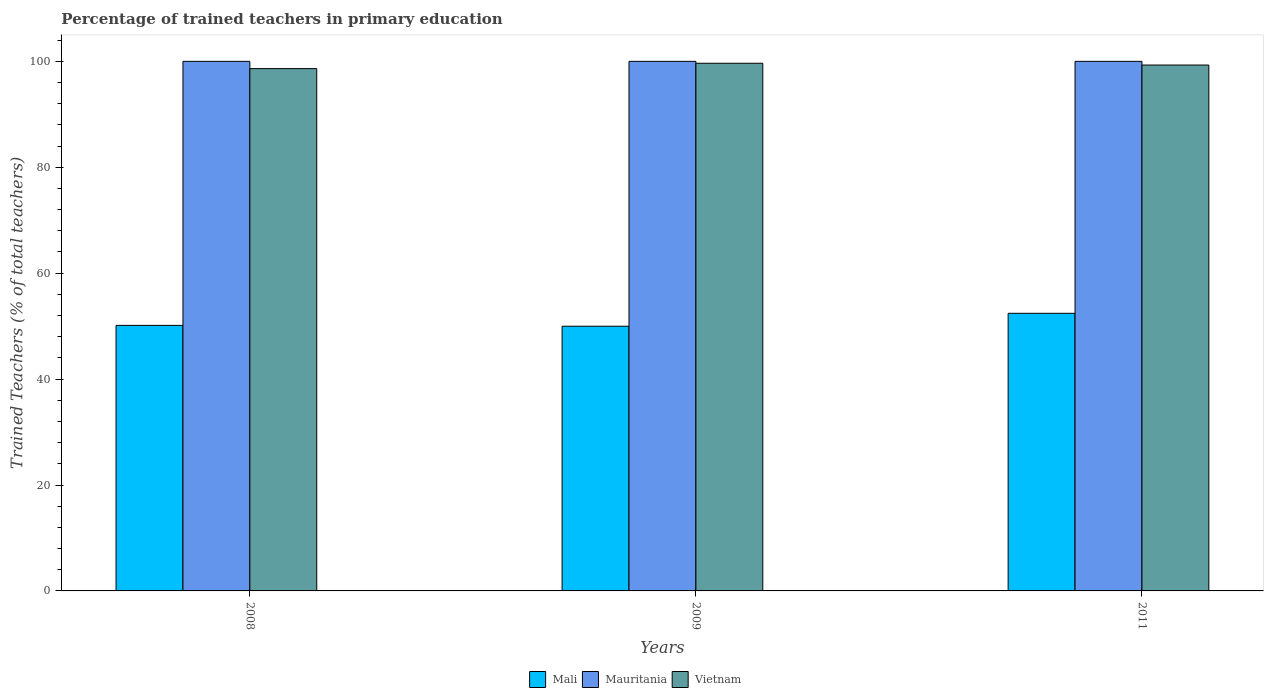How many different coloured bars are there?
Give a very brief answer. 3. Are the number of bars per tick equal to the number of legend labels?
Ensure brevity in your answer.  Yes. What is the percentage of trained teachers in Vietnam in 2008?
Offer a very short reply. 98.63. Across all years, what is the maximum percentage of trained teachers in Mali?
Provide a succinct answer. 52.42. Across all years, what is the minimum percentage of trained teachers in Mauritania?
Offer a very short reply. 100. In which year was the percentage of trained teachers in Mauritania maximum?
Offer a terse response. 2008. What is the total percentage of trained teachers in Mauritania in the graph?
Your response must be concise. 300. What is the difference between the percentage of trained teachers in Mali in 2008 and that in 2011?
Keep it short and to the point. -2.28. What is the difference between the percentage of trained teachers in Mauritania in 2011 and the percentage of trained teachers in Mali in 2009?
Keep it short and to the point. 50.02. What is the average percentage of trained teachers in Vietnam per year?
Provide a short and direct response. 99.19. In the year 2009, what is the difference between the percentage of trained teachers in Mali and percentage of trained teachers in Mauritania?
Offer a terse response. -50.02. What is the ratio of the percentage of trained teachers in Mali in 2008 to that in 2011?
Offer a terse response. 0.96. What is the difference between the highest and the second highest percentage of trained teachers in Mali?
Provide a succinct answer. 2.28. What is the difference between the highest and the lowest percentage of trained teachers in Vietnam?
Your answer should be very brief. 1.01. In how many years, is the percentage of trained teachers in Mauritania greater than the average percentage of trained teachers in Mauritania taken over all years?
Make the answer very short. 0. What does the 3rd bar from the left in 2008 represents?
Your answer should be very brief. Vietnam. What does the 2nd bar from the right in 2011 represents?
Ensure brevity in your answer.  Mauritania. Is it the case that in every year, the sum of the percentage of trained teachers in Mauritania and percentage of trained teachers in Mali is greater than the percentage of trained teachers in Vietnam?
Offer a very short reply. Yes. How many bars are there?
Your response must be concise. 9. Are all the bars in the graph horizontal?
Provide a short and direct response. No. How many years are there in the graph?
Provide a succinct answer. 3. What is the difference between two consecutive major ticks on the Y-axis?
Your answer should be compact. 20. Where does the legend appear in the graph?
Ensure brevity in your answer.  Bottom center. How are the legend labels stacked?
Provide a succinct answer. Horizontal. What is the title of the graph?
Your answer should be very brief. Percentage of trained teachers in primary education. Does "Gabon" appear as one of the legend labels in the graph?
Your response must be concise. No. What is the label or title of the Y-axis?
Ensure brevity in your answer.  Trained Teachers (% of total teachers). What is the Trained Teachers (% of total teachers) of Mali in 2008?
Give a very brief answer. 50.14. What is the Trained Teachers (% of total teachers) of Vietnam in 2008?
Keep it short and to the point. 98.63. What is the Trained Teachers (% of total teachers) in Mali in 2009?
Give a very brief answer. 49.98. What is the Trained Teachers (% of total teachers) in Mauritania in 2009?
Your answer should be very brief. 100. What is the Trained Teachers (% of total teachers) in Vietnam in 2009?
Your answer should be compact. 99.64. What is the Trained Teachers (% of total teachers) in Mali in 2011?
Your response must be concise. 52.42. What is the Trained Teachers (% of total teachers) of Vietnam in 2011?
Make the answer very short. 99.3. Across all years, what is the maximum Trained Teachers (% of total teachers) of Mali?
Provide a succinct answer. 52.42. Across all years, what is the maximum Trained Teachers (% of total teachers) of Vietnam?
Your response must be concise. 99.64. Across all years, what is the minimum Trained Teachers (% of total teachers) in Mali?
Make the answer very short. 49.98. Across all years, what is the minimum Trained Teachers (% of total teachers) of Vietnam?
Keep it short and to the point. 98.63. What is the total Trained Teachers (% of total teachers) in Mali in the graph?
Make the answer very short. 152.55. What is the total Trained Teachers (% of total teachers) of Mauritania in the graph?
Offer a very short reply. 300. What is the total Trained Teachers (% of total teachers) in Vietnam in the graph?
Your answer should be very brief. 297.57. What is the difference between the Trained Teachers (% of total teachers) in Mali in 2008 and that in 2009?
Your answer should be compact. 0.16. What is the difference between the Trained Teachers (% of total teachers) of Mauritania in 2008 and that in 2009?
Keep it short and to the point. 0. What is the difference between the Trained Teachers (% of total teachers) in Vietnam in 2008 and that in 2009?
Your answer should be compact. -1.01. What is the difference between the Trained Teachers (% of total teachers) of Mali in 2008 and that in 2011?
Provide a short and direct response. -2.28. What is the difference between the Trained Teachers (% of total teachers) of Vietnam in 2008 and that in 2011?
Offer a terse response. -0.68. What is the difference between the Trained Teachers (% of total teachers) of Mali in 2009 and that in 2011?
Your response must be concise. -2.44. What is the difference between the Trained Teachers (% of total teachers) in Vietnam in 2009 and that in 2011?
Provide a succinct answer. 0.34. What is the difference between the Trained Teachers (% of total teachers) in Mali in 2008 and the Trained Teachers (% of total teachers) in Mauritania in 2009?
Your response must be concise. -49.86. What is the difference between the Trained Teachers (% of total teachers) in Mali in 2008 and the Trained Teachers (% of total teachers) in Vietnam in 2009?
Your answer should be very brief. -49.5. What is the difference between the Trained Teachers (% of total teachers) of Mauritania in 2008 and the Trained Teachers (% of total teachers) of Vietnam in 2009?
Make the answer very short. 0.36. What is the difference between the Trained Teachers (% of total teachers) of Mali in 2008 and the Trained Teachers (% of total teachers) of Mauritania in 2011?
Keep it short and to the point. -49.86. What is the difference between the Trained Teachers (% of total teachers) of Mali in 2008 and the Trained Teachers (% of total teachers) of Vietnam in 2011?
Give a very brief answer. -49.16. What is the difference between the Trained Teachers (% of total teachers) in Mauritania in 2008 and the Trained Teachers (% of total teachers) in Vietnam in 2011?
Your response must be concise. 0.7. What is the difference between the Trained Teachers (% of total teachers) in Mali in 2009 and the Trained Teachers (% of total teachers) in Mauritania in 2011?
Provide a succinct answer. -50.02. What is the difference between the Trained Teachers (% of total teachers) of Mali in 2009 and the Trained Teachers (% of total teachers) of Vietnam in 2011?
Keep it short and to the point. -49.32. What is the difference between the Trained Teachers (% of total teachers) in Mauritania in 2009 and the Trained Teachers (% of total teachers) in Vietnam in 2011?
Offer a terse response. 0.7. What is the average Trained Teachers (% of total teachers) of Mali per year?
Provide a short and direct response. 50.85. What is the average Trained Teachers (% of total teachers) of Vietnam per year?
Your answer should be compact. 99.19. In the year 2008, what is the difference between the Trained Teachers (% of total teachers) in Mali and Trained Teachers (% of total teachers) in Mauritania?
Your response must be concise. -49.86. In the year 2008, what is the difference between the Trained Teachers (% of total teachers) in Mali and Trained Teachers (% of total teachers) in Vietnam?
Give a very brief answer. -48.48. In the year 2008, what is the difference between the Trained Teachers (% of total teachers) in Mauritania and Trained Teachers (% of total teachers) in Vietnam?
Your answer should be compact. 1.37. In the year 2009, what is the difference between the Trained Teachers (% of total teachers) of Mali and Trained Teachers (% of total teachers) of Mauritania?
Your response must be concise. -50.02. In the year 2009, what is the difference between the Trained Teachers (% of total teachers) in Mali and Trained Teachers (% of total teachers) in Vietnam?
Ensure brevity in your answer.  -49.66. In the year 2009, what is the difference between the Trained Teachers (% of total teachers) in Mauritania and Trained Teachers (% of total teachers) in Vietnam?
Provide a succinct answer. 0.36. In the year 2011, what is the difference between the Trained Teachers (% of total teachers) in Mali and Trained Teachers (% of total teachers) in Mauritania?
Your answer should be very brief. -47.58. In the year 2011, what is the difference between the Trained Teachers (% of total teachers) of Mali and Trained Teachers (% of total teachers) of Vietnam?
Your response must be concise. -46.88. In the year 2011, what is the difference between the Trained Teachers (% of total teachers) in Mauritania and Trained Teachers (% of total teachers) in Vietnam?
Offer a very short reply. 0.7. What is the ratio of the Trained Teachers (% of total teachers) of Mauritania in 2008 to that in 2009?
Give a very brief answer. 1. What is the ratio of the Trained Teachers (% of total teachers) of Vietnam in 2008 to that in 2009?
Your answer should be compact. 0.99. What is the ratio of the Trained Teachers (% of total teachers) of Mali in 2008 to that in 2011?
Offer a terse response. 0.96. What is the ratio of the Trained Teachers (% of total teachers) in Mauritania in 2008 to that in 2011?
Offer a very short reply. 1. What is the ratio of the Trained Teachers (% of total teachers) of Vietnam in 2008 to that in 2011?
Your response must be concise. 0.99. What is the ratio of the Trained Teachers (% of total teachers) of Mali in 2009 to that in 2011?
Offer a terse response. 0.95. What is the difference between the highest and the second highest Trained Teachers (% of total teachers) in Mali?
Provide a succinct answer. 2.28. What is the difference between the highest and the second highest Trained Teachers (% of total teachers) in Mauritania?
Provide a short and direct response. 0. What is the difference between the highest and the second highest Trained Teachers (% of total teachers) in Vietnam?
Provide a succinct answer. 0.34. What is the difference between the highest and the lowest Trained Teachers (% of total teachers) of Mali?
Your answer should be very brief. 2.44. What is the difference between the highest and the lowest Trained Teachers (% of total teachers) of Vietnam?
Your response must be concise. 1.01. 